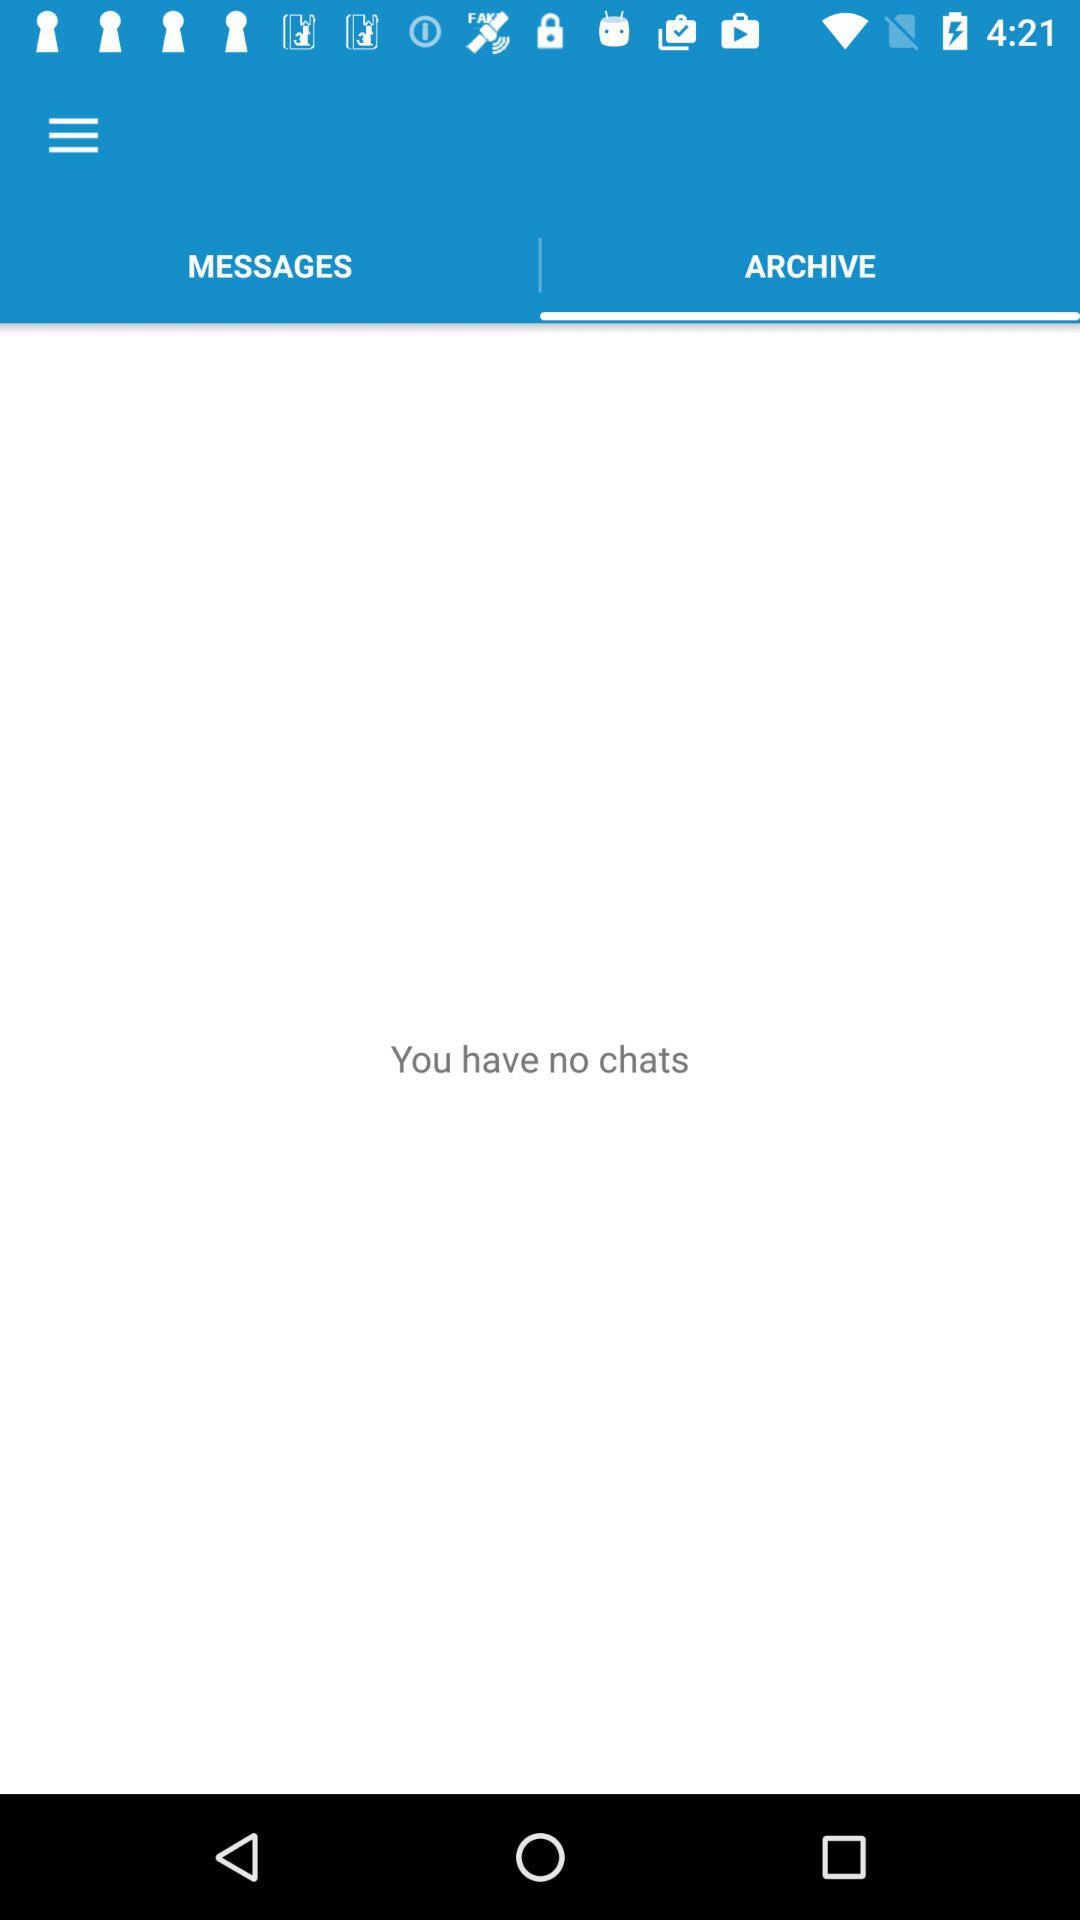Are there any chats available? There are no chats available. 